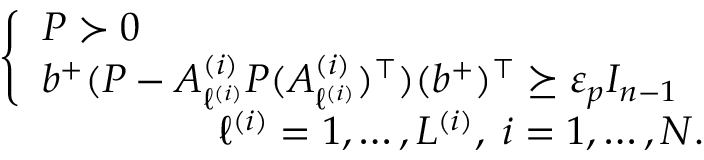<formula> <loc_0><loc_0><loc_500><loc_500>\begin{array} { r } { \left \{ \begin{array} { l } { P \succ 0 } \\ { b ^ { + } ( P - A _ { \ell ^ { ( i ) } } ^ { ( i ) } P ( A _ { \ell ^ { ( i ) } } ^ { ( i ) } ) ^ { \top } ) ( b ^ { + } ) ^ { \top } \succeq \varepsilon _ { p } I _ { n - 1 } } \end{array} } \\ { \ell ^ { ( i ) } = 1 , \dots , L ^ { ( i ) } , \, i = 1 , \dots , N . } \end{array}</formula> 